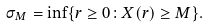Convert formula to latex. <formula><loc_0><loc_0><loc_500><loc_500>\sigma _ { M } = \inf \{ r \geq 0 \colon X ( r ) \geq M \} .</formula> 